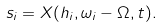<formula> <loc_0><loc_0><loc_500><loc_500>s _ { i } = X ( h _ { i } , \omega _ { i } - \Omega , t ) .</formula> 